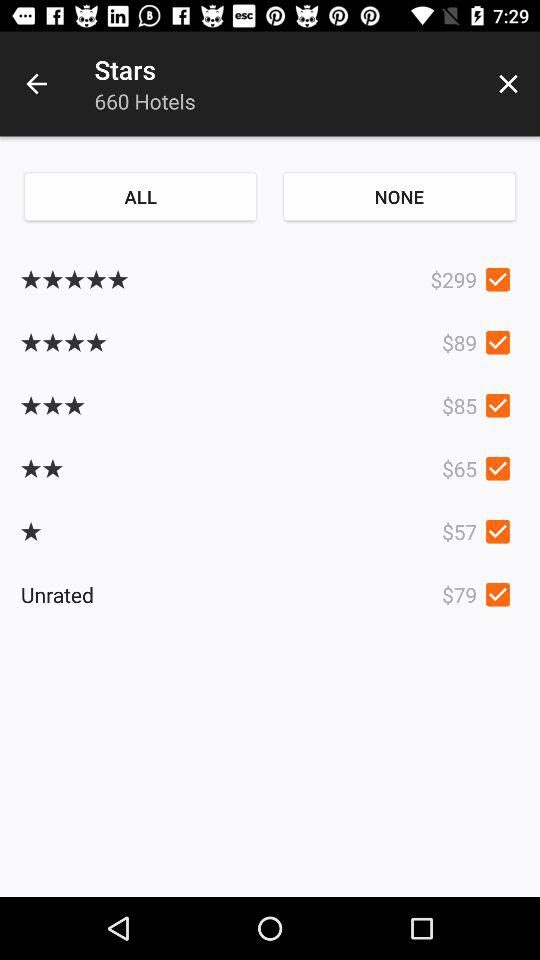What is the number of hotels? The number of hotels is 660. 